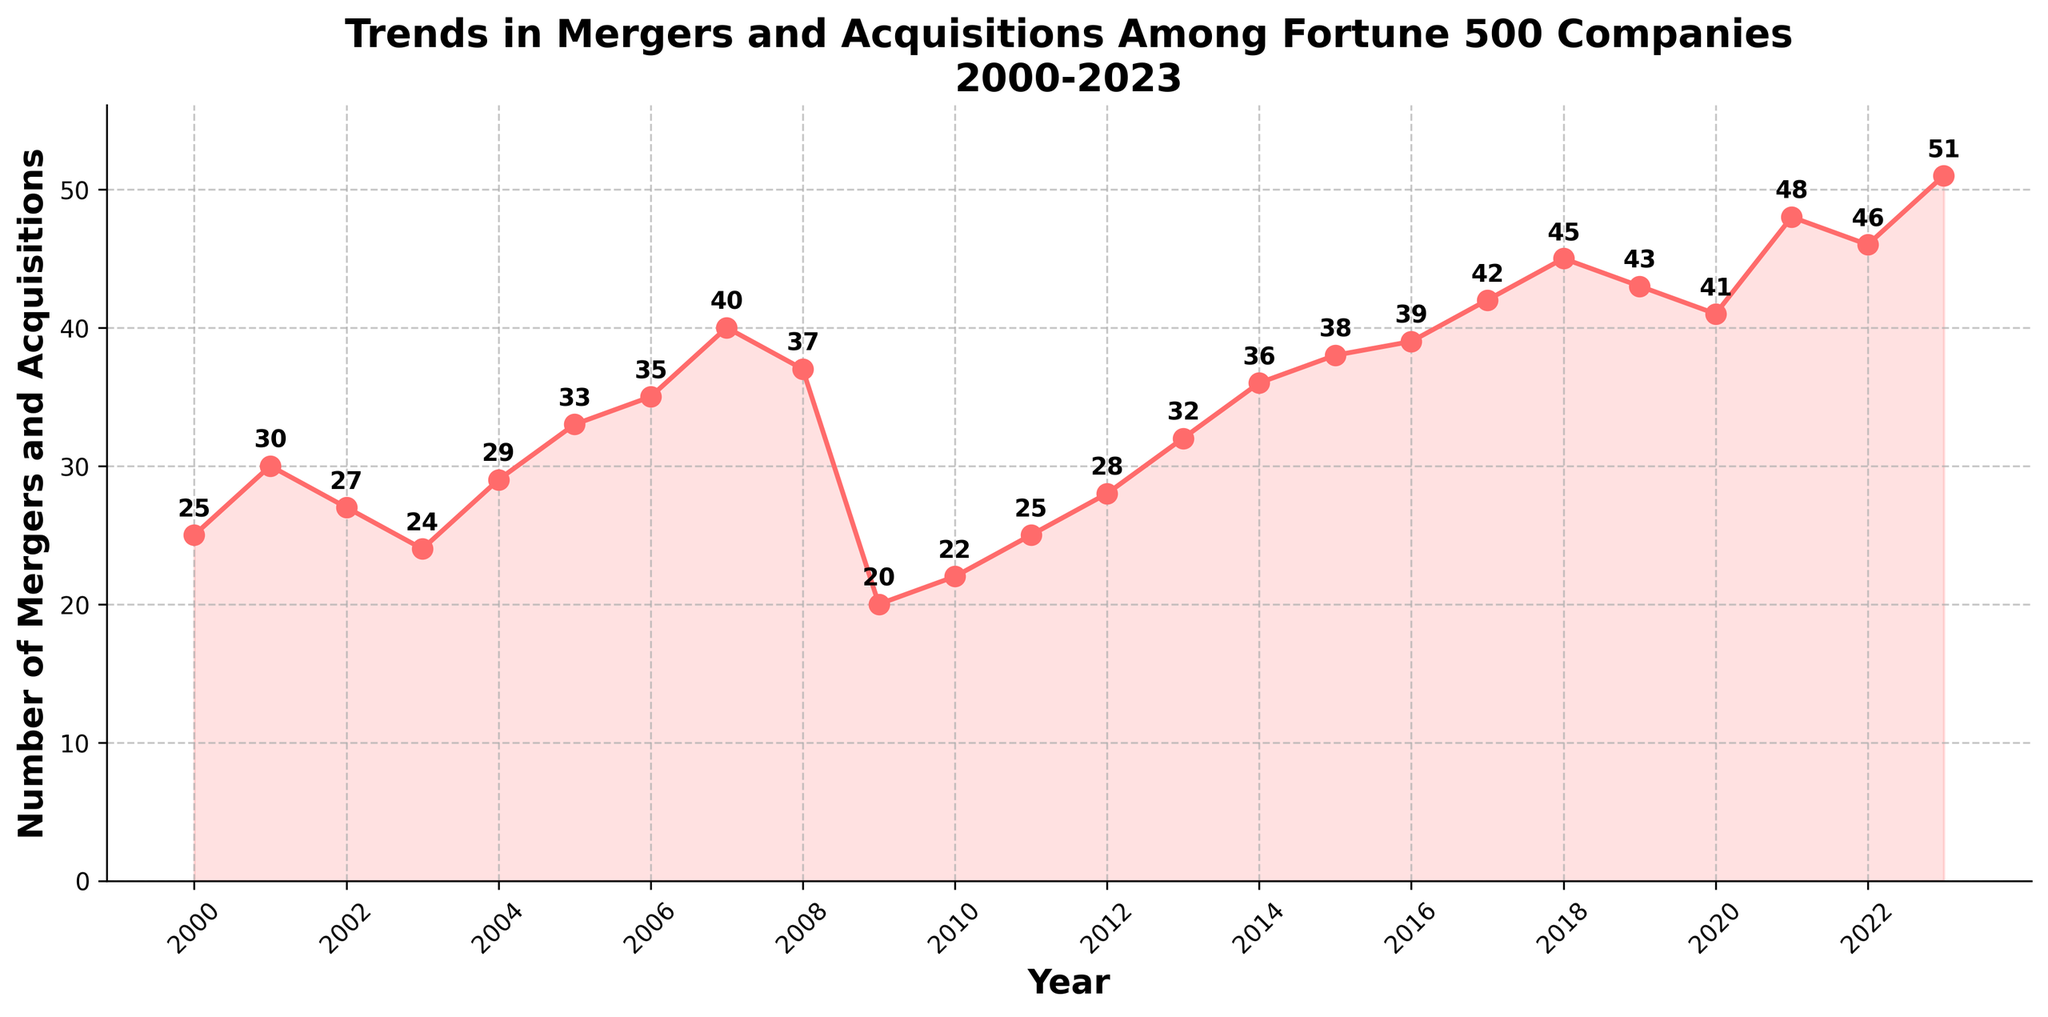What does the figure's title indicate? The title of the figure indicates the subject and time range of the data being represented. It specifies that the figure reflects "Trends in Mergers and Acquisitions Among Fortune 500 Companies" from 2000 to 2023.
Answer: Trends in Mergers and Acquisitions Among Fortune 500 Companies 2000-2023 What are the units used on the y-axis? The y-axis units are indicated by its label, which mentions "Number of Mergers and Acquisitions." This means the values represent counts of mergers and acquisitions.
Answer: Number of Mergers and Acquisitions How many data points are there in the figure? By looking at the x-axis from 2000 to 2023, we can count the yearly data points present in the time series.
Answer: 24 Which year shows the highest number of mergers and acquisitions? By examining the peaks in the plot and their corresponding year labels, we can identify that 2023 has the highest value.
Answer: 2023 How many mergers and acquisitions occurred in 2023? We refer to the data point for the year 2023 and see the value plotted there, which is labeled as 51.
Answer: 51 Between which two consecutive years is the largest increase in mergers and acquisitions observed? We need to look for the largest upward jump between any two consecutive years. This can be identified visually or by calculating the differences between consecutive points. The largest jump is between 2020 (41) and 2021 (48).
Answer: 2020 to 2021 Which year experienced the biggest decline in the number of mergers and acquisitions compared to the previous year? Similar to finding the largest increase, we need to look for the steepest downward slope between consecutive years. This occurs between 2008 (37) and 2009 (20).
Answer: 2008 to 2009 What is the average number of mergers and acquisitions per year over the entire period? Sum up all the yearly values and divide by the number of years (24). The total sum is 824, so 824 / 24 = 34.33.
Answer: 34.33 How did the number of mergers and acquisitions change during the 2008-2009 period? By comparing the values for 2008 and 2009, we see a significant drop from 37 to 20, indicating a sharp decline.
Answer: Decreased Is there a general upward or downward trend in the number of mergers and acquisitions over the entire period? By examining the overall shape of the plot from 2000 to 2023, we can see that the general trend is upward, with more fluctuations rising over time.
Answer: Upward 